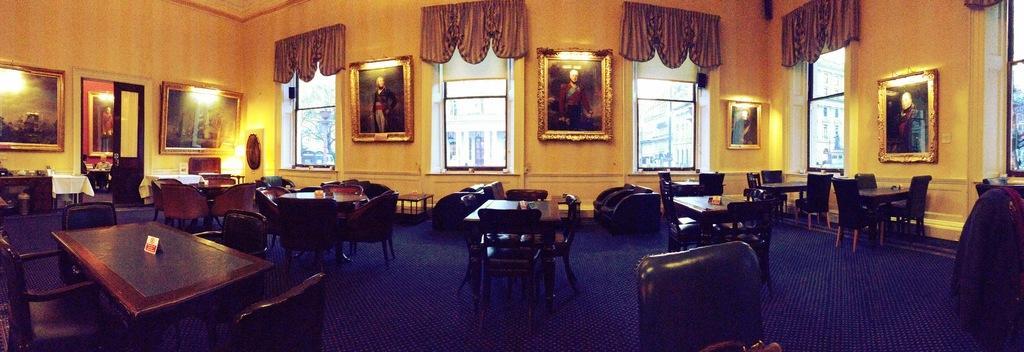Describe this image in one or two sentences. In this image I can see number of chairs around the table which are brown in color. I can see the blue colored floor. In the background I can see the cream colored wall, few curtains, few photo frames attached to the wall, few lights and few windows through which I can see few buildings and a tree. 